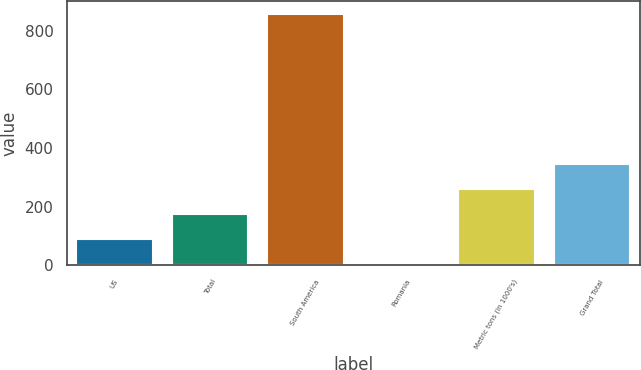Convert chart to OTSL. <chart><loc_0><loc_0><loc_500><loc_500><bar_chart><fcel>US<fcel>Total<fcel>South America<fcel>Romania<fcel>Metric tons (in 1000's)<fcel>Grand Total<nl><fcel>88.5<fcel>174<fcel>858<fcel>3<fcel>259.5<fcel>345<nl></chart> 